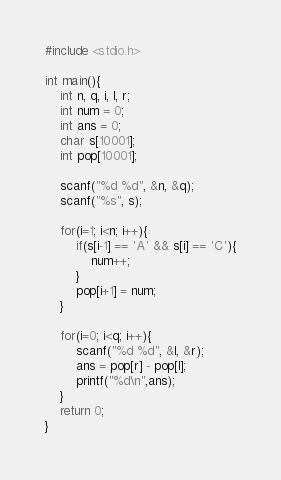Convert code to text. <code><loc_0><loc_0><loc_500><loc_500><_C_>#include <stdio.h>

int main(){
	int n, q, i, l, r;
  	int num = 0;
    int ans = 0;
  	char s[10001];
  	int pop[10001];
  
  	scanf("%d %d", &n, &q);
  	scanf("%s", s);
  
    for(i=1; i<n; i++){
       	if(s[i-1] == 'A' && s[i] == 'C'){
           	num++;
        }
      	pop[i+1] = num;
    }
  
   	for(i=0; i<q; i++){
    	scanf("%d %d", &l, &r);
      	ans = pop[r] - pop[l];
        printf("%d\n",ans);
    }
	return 0;
}</code> 